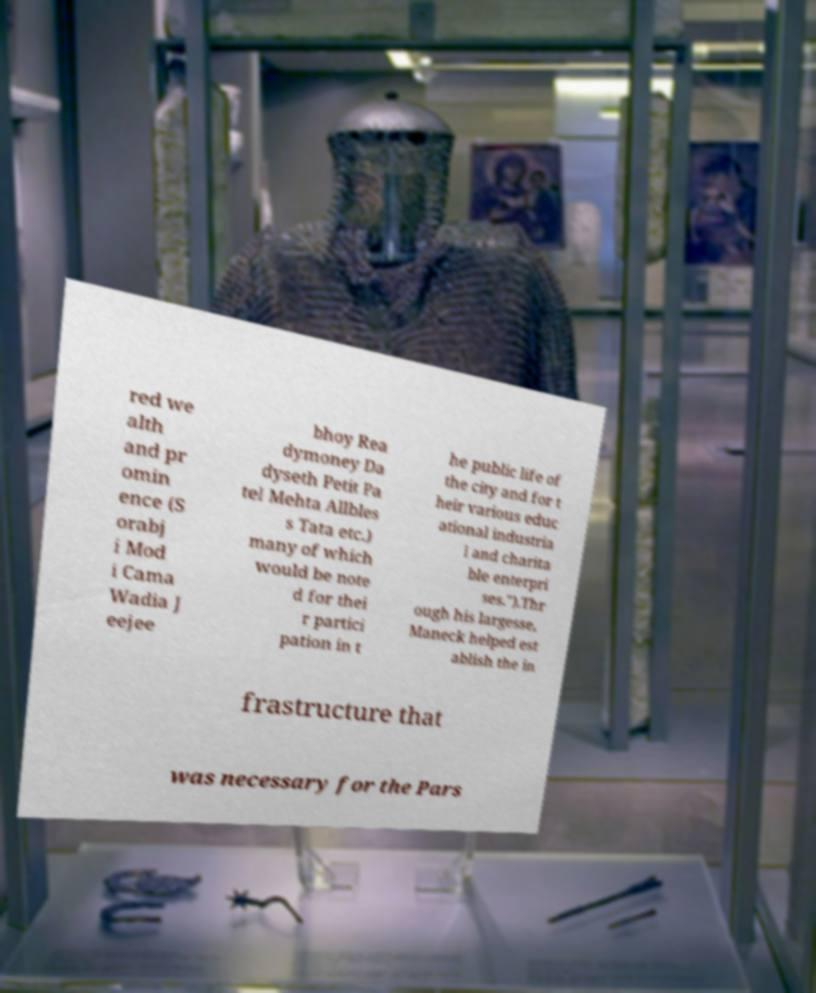Can you accurately transcribe the text from the provided image for me? red we alth and pr omin ence (S orabj i Mod i Cama Wadia J eejee bhoy Rea dymoney Da dyseth Petit Pa tel Mehta Allbles s Tata etc.) many of which would be note d for thei r partici pation in t he public life of the city and for t heir various educ ational industria l and charita ble enterpri ses.").Thr ough his largesse, Maneck helped est ablish the in frastructure that was necessary for the Pars 